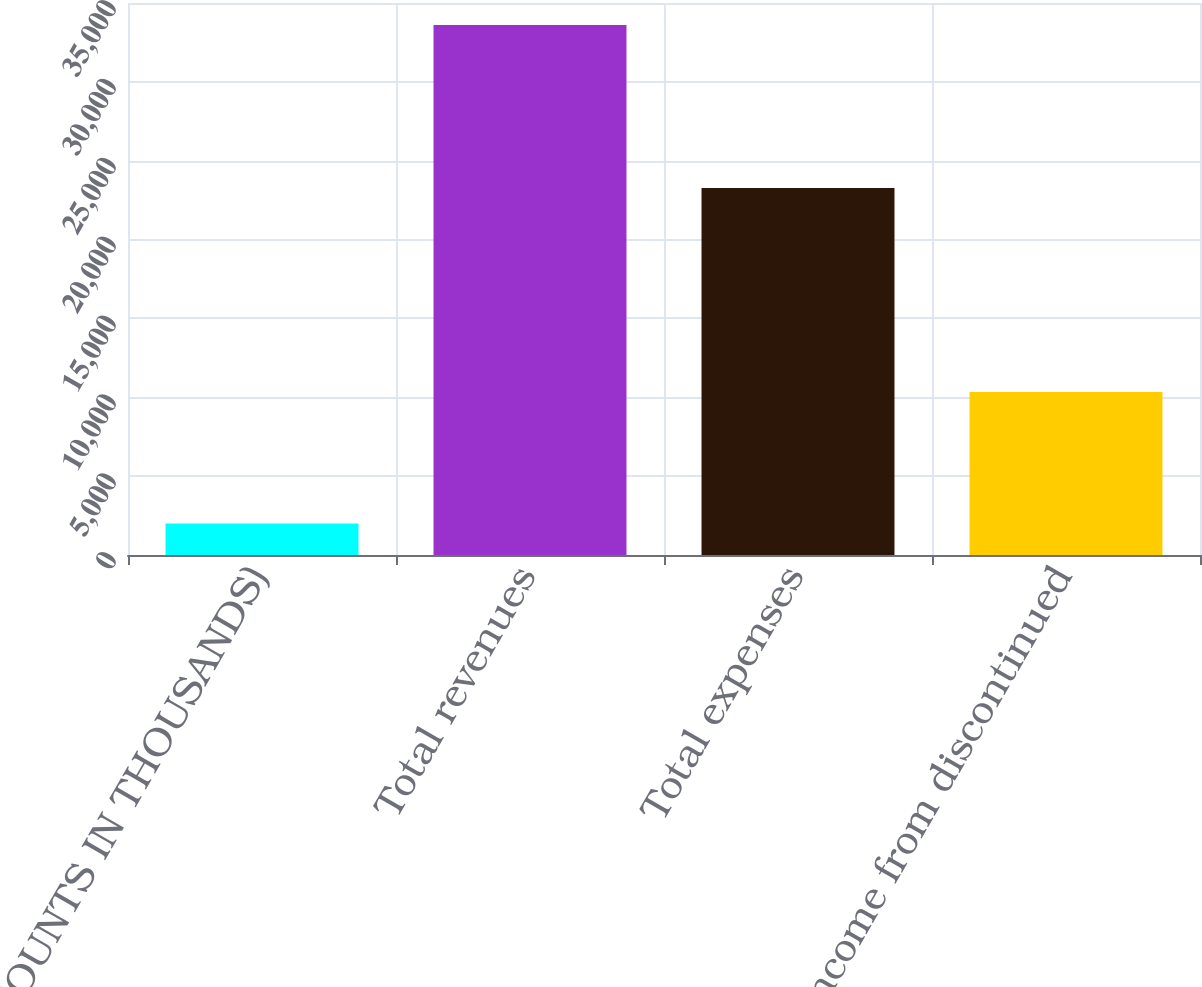Convert chart to OTSL. <chart><loc_0><loc_0><loc_500><loc_500><bar_chart><fcel>(AMOUNTS IN THOUSANDS)<fcel>Total revenues<fcel>Total expenses<fcel>Income from discontinued<nl><fcel>2001<fcel>33612<fcel>23270<fcel>10342<nl></chart> 